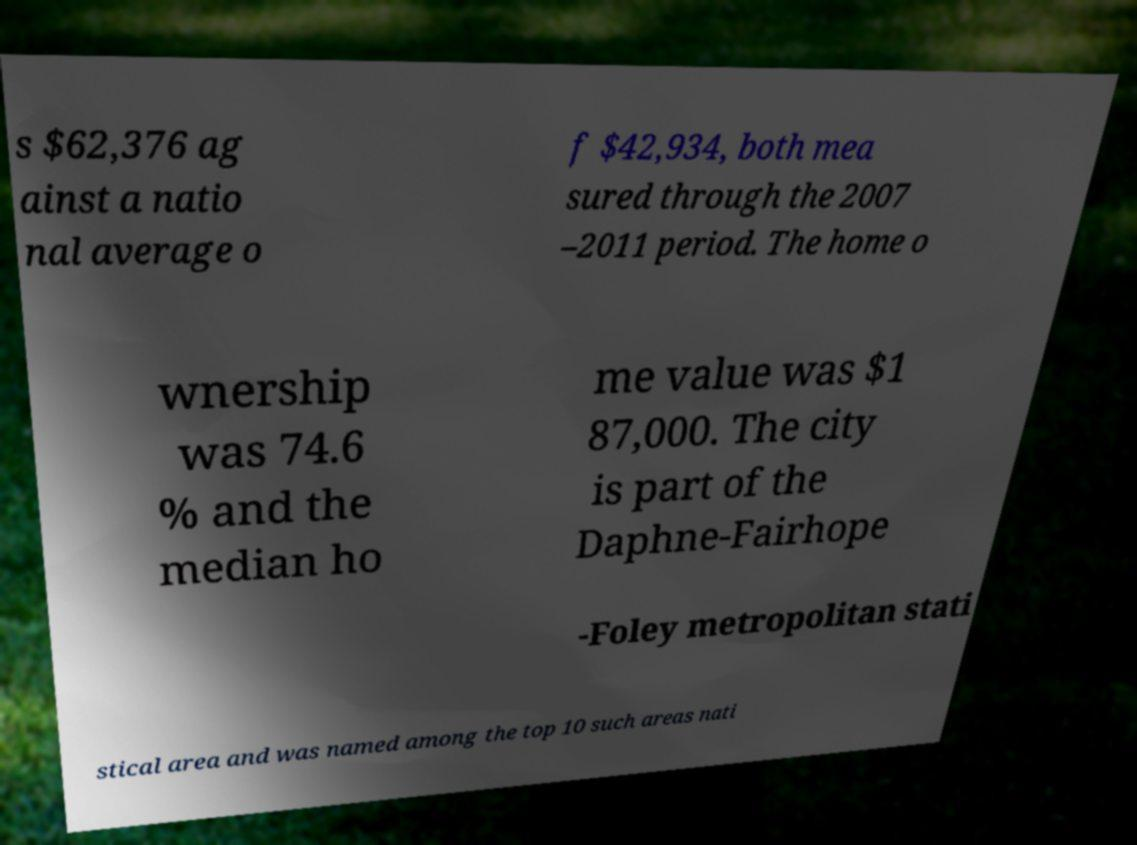Can you accurately transcribe the text from the provided image for me? s $62,376 ag ainst a natio nal average o f $42,934, both mea sured through the 2007 –2011 period. The home o wnership was 74.6 % and the median ho me value was $1 87,000. The city is part of the Daphne-Fairhope -Foley metropolitan stati stical area and was named among the top 10 such areas nati 